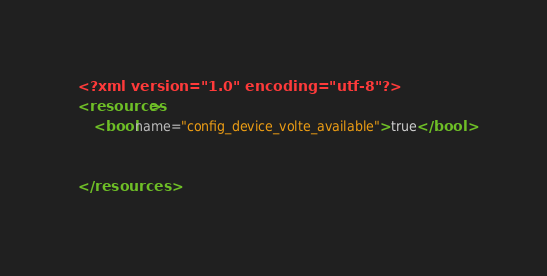Convert code to text. <code><loc_0><loc_0><loc_500><loc_500><_XML_><?xml version="1.0" encoding="utf-8"?>
<resources>
    <bool name="config_device_volte_available">true</bool>
    
    
</resources>
</code> 